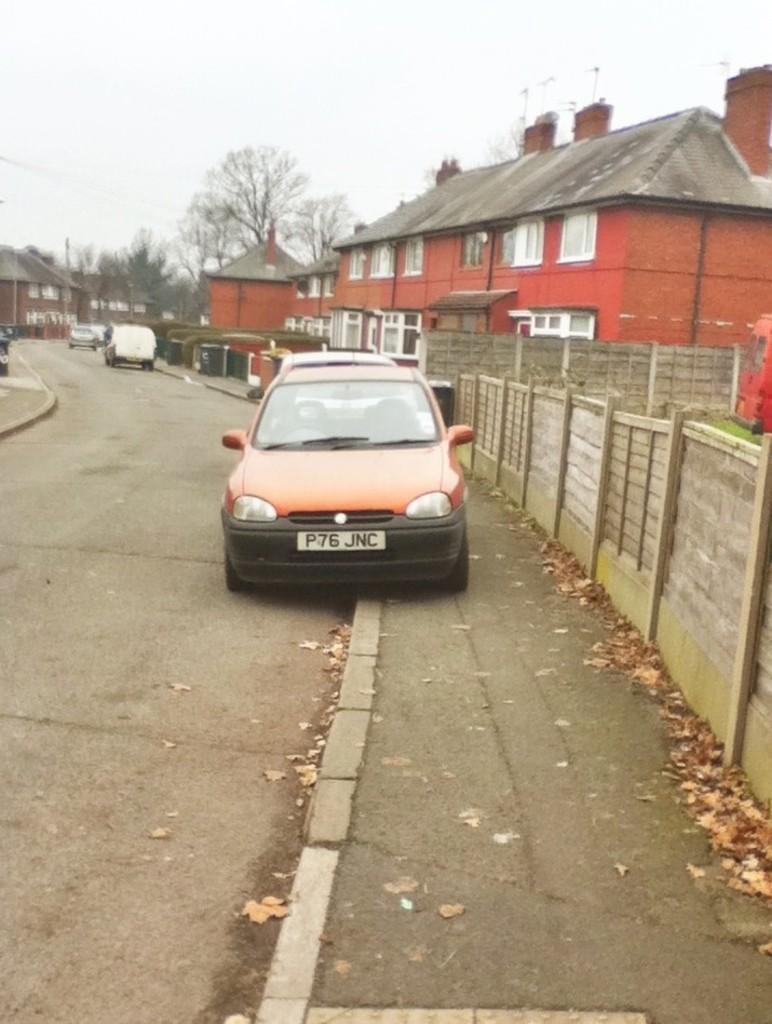Could you give a brief overview of what you see in this image? In this picture we can see vehicles on the road and in the background we can see buildings, trees, plants and the sky. 